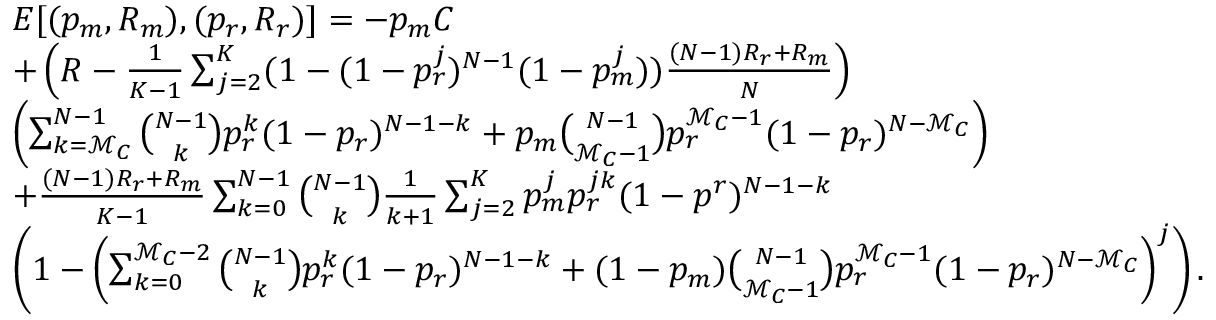<formula> <loc_0><loc_0><loc_500><loc_500>\begin{array} { r l } & { E [ ( p _ { m } , R _ { m } ) , ( p _ { r } , R _ { r } ) ] = - p _ { m } C } \\ & { + \left ( R - \frac { 1 } { K - 1 } \sum _ { j = 2 } ^ { K } ( 1 - ( 1 - p _ { r } ^ { j } ) ^ { N - 1 } ( 1 - p _ { m } ^ { j } ) ) \frac { ( N - 1 ) R _ { r } + R _ { m } } { N } \right ) } \\ & { \left ( \sum _ { k = \mathcal { M } _ { C } } ^ { N - 1 } { \binom { N - 1 } { k } } p _ { r } ^ { k } ( 1 - p _ { r } ) ^ { N - 1 - k } + p _ { m } { \binom { N - 1 } { \mathcal { M } _ { C } - 1 } } p _ { r } ^ { \mathcal { M } _ { C } - 1 } ( 1 - p _ { r } ) ^ { N - \mathcal { M } _ { C } } \right ) } \\ & { + \frac { ( N - 1 ) R _ { r } + R _ { m } } { K - 1 } \sum _ { k = 0 } ^ { N - 1 } { \binom { N - 1 } { k } } \frac { 1 } { k + 1 } \sum _ { j = 2 } ^ { K } p _ { m } ^ { j } p _ { r } ^ { j k } ( 1 - p ^ { r } ) ^ { N - 1 - k } } \\ & { \left ( 1 - \left ( \sum _ { k = 0 } ^ { \mathcal { M } _ { C } - 2 } { \binom { N - 1 } { k } } p _ { r } ^ { k } ( 1 - p _ { r } ) ^ { N - 1 - k } + ( 1 - p _ { m } ) { \binom { N - 1 } { \mathcal { M } _ { C } - 1 } } p _ { r } ^ { \mathcal { M } _ { C } - 1 } ( 1 - p _ { r } ) ^ { N - \mathcal { M } _ { C } } \right ) ^ { j } \right ) . } \end{array}</formula> 